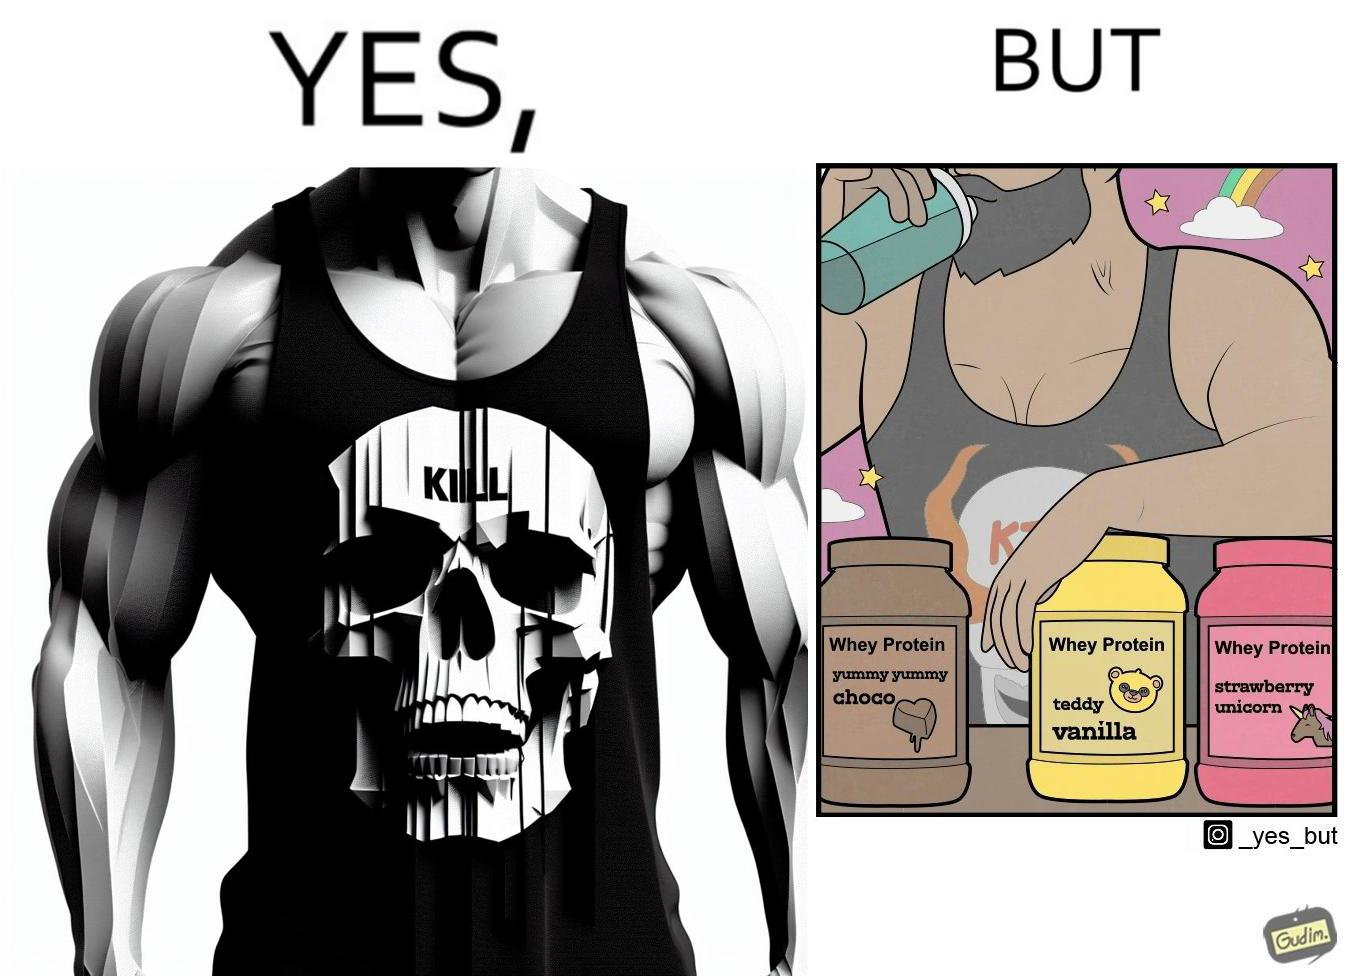Is this image satirical or non-satirical? Yes, this image is satirical. 